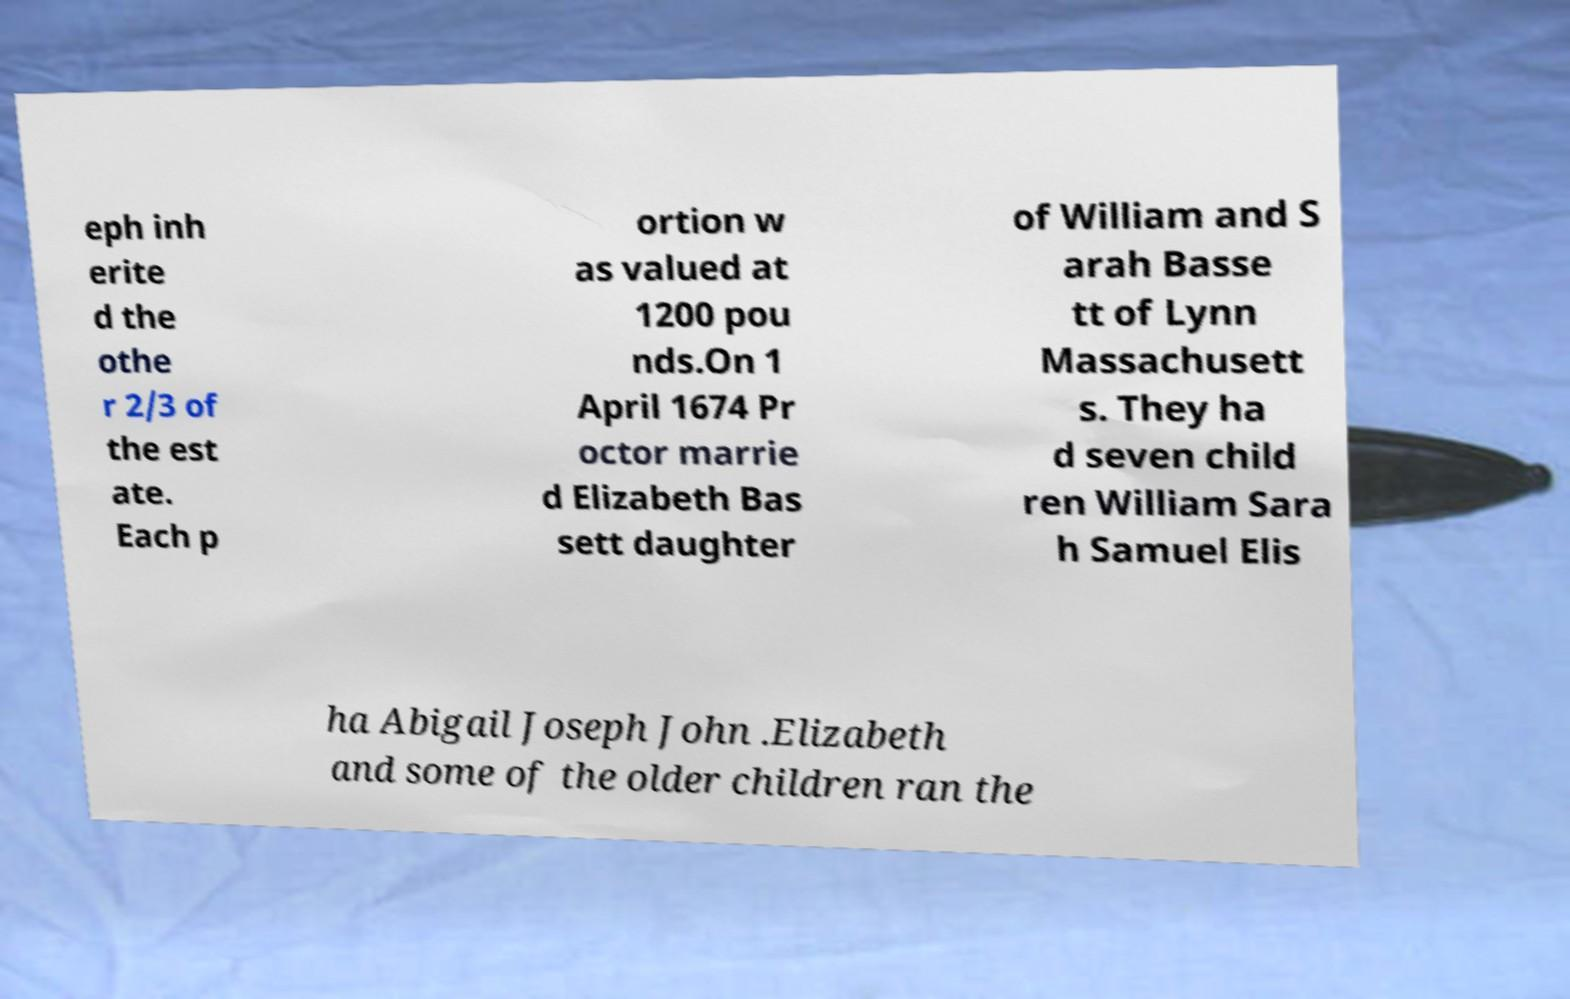What messages or text are displayed in this image? I need them in a readable, typed format. eph inh erite d the othe r 2/3 of the est ate. Each p ortion w as valued at 1200 pou nds.On 1 April 1674 Pr octor marrie d Elizabeth Bas sett daughter of William and S arah Basse tt of Lynn Massachusett s. They ha d seven child ren William Sara h Samuel Elis ha Abigail Joseph John .Elizabeth and some of the older children ran the 